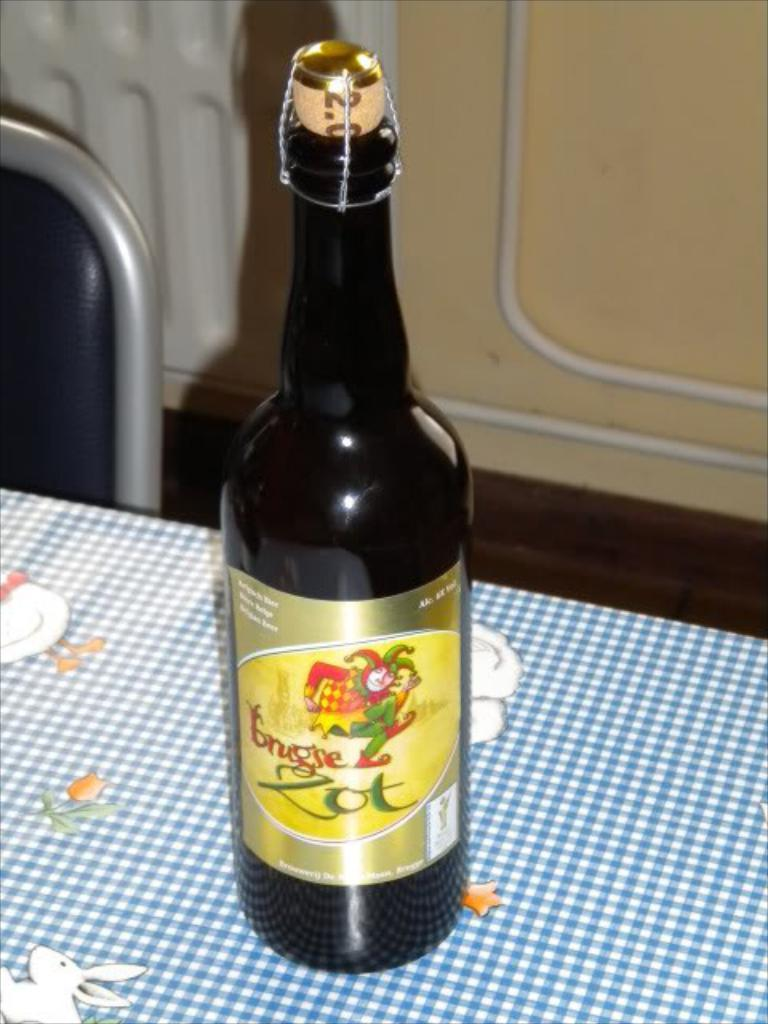What object is placed on the table in the image? There is a bottle on the table. What else is on the table? There is a cloth on the table. Can you describe the possible seating arrangement in the image? There might be a chair in front of the table. What type of water is flowing in the scene depicted in the image? There is no scene or water present in the image; it only features a table with a bottle and a cloth. 